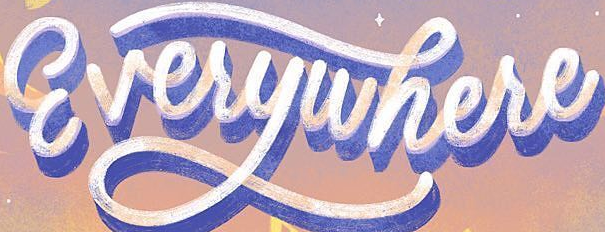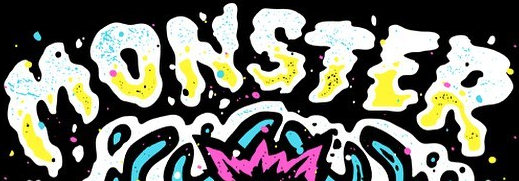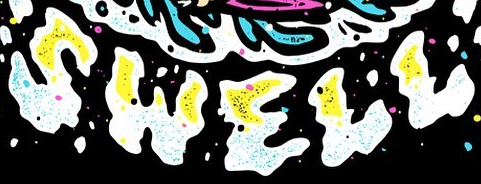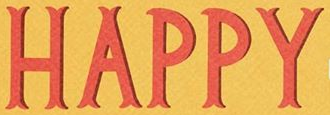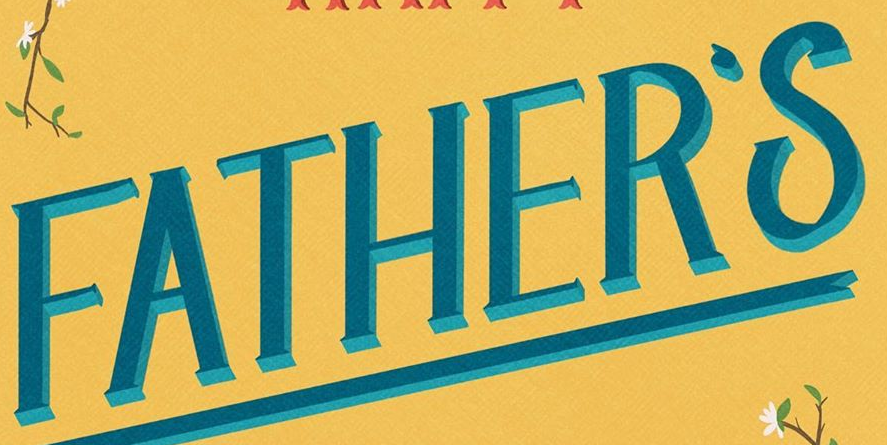Transcribe the words shown in these images in order, separated by a semicolon. Everywhere; MONSTER; SWELL; HAPPY; FATHER'S 